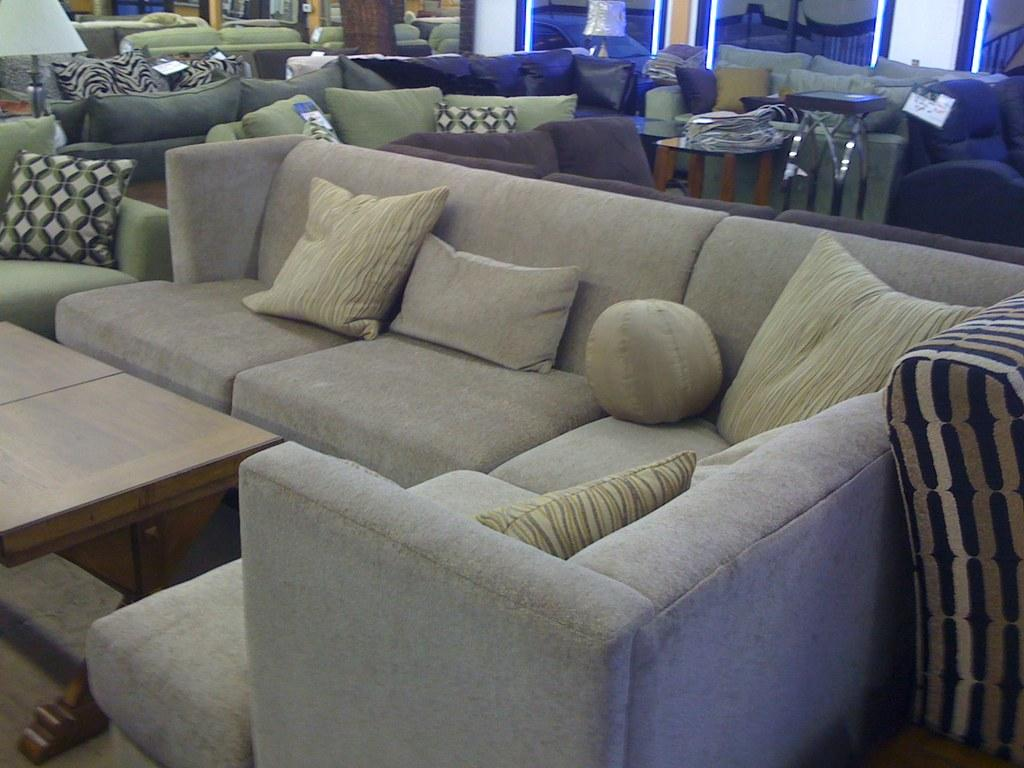What type of furniture can be seen in the image? There are several types of sofas in the image. What other objects are present in the image besides sofas? There are center tables in the image. Are there any reflective surfaces in the image? Yes, there are mirrors in the image. What type of lighting is present in the image? LED lights are present in the image. What is the tendency of the queen to visit the location depicted in the image? There is no queen or indication of a specific location in the image, so it is not possible to determine any tendencies related to the queen. 